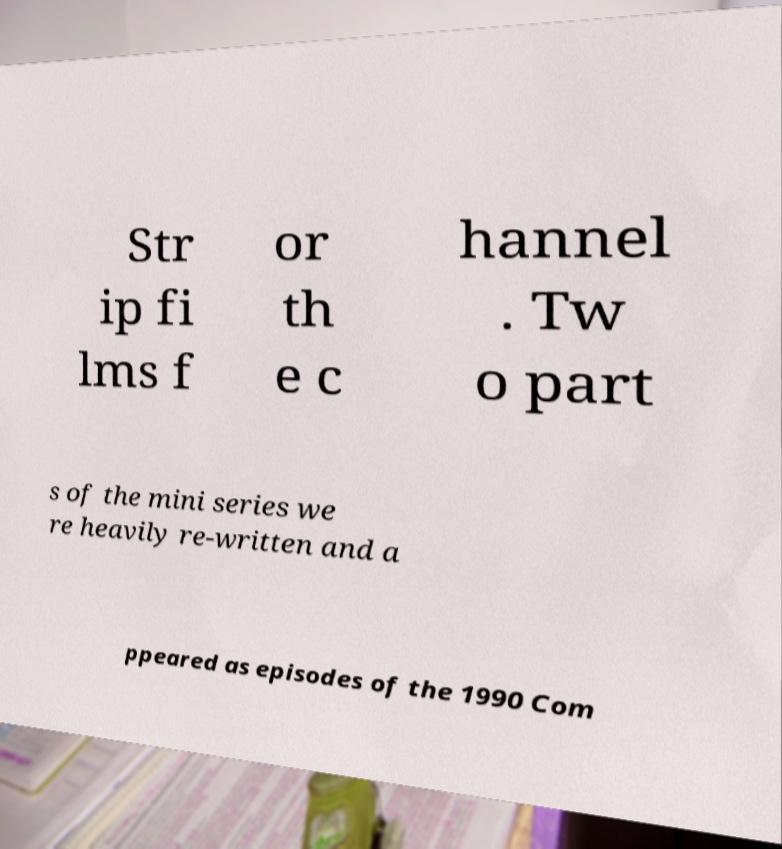Can you read and provide the text displayed in the image?This photo seems to have some interesting text. Can you extract and type it out for me? Str ip fi lms f or th e c hannel . Tw o part s of the mini series we re heavily re-written and a ppeared as episodes of the 1990 Com 